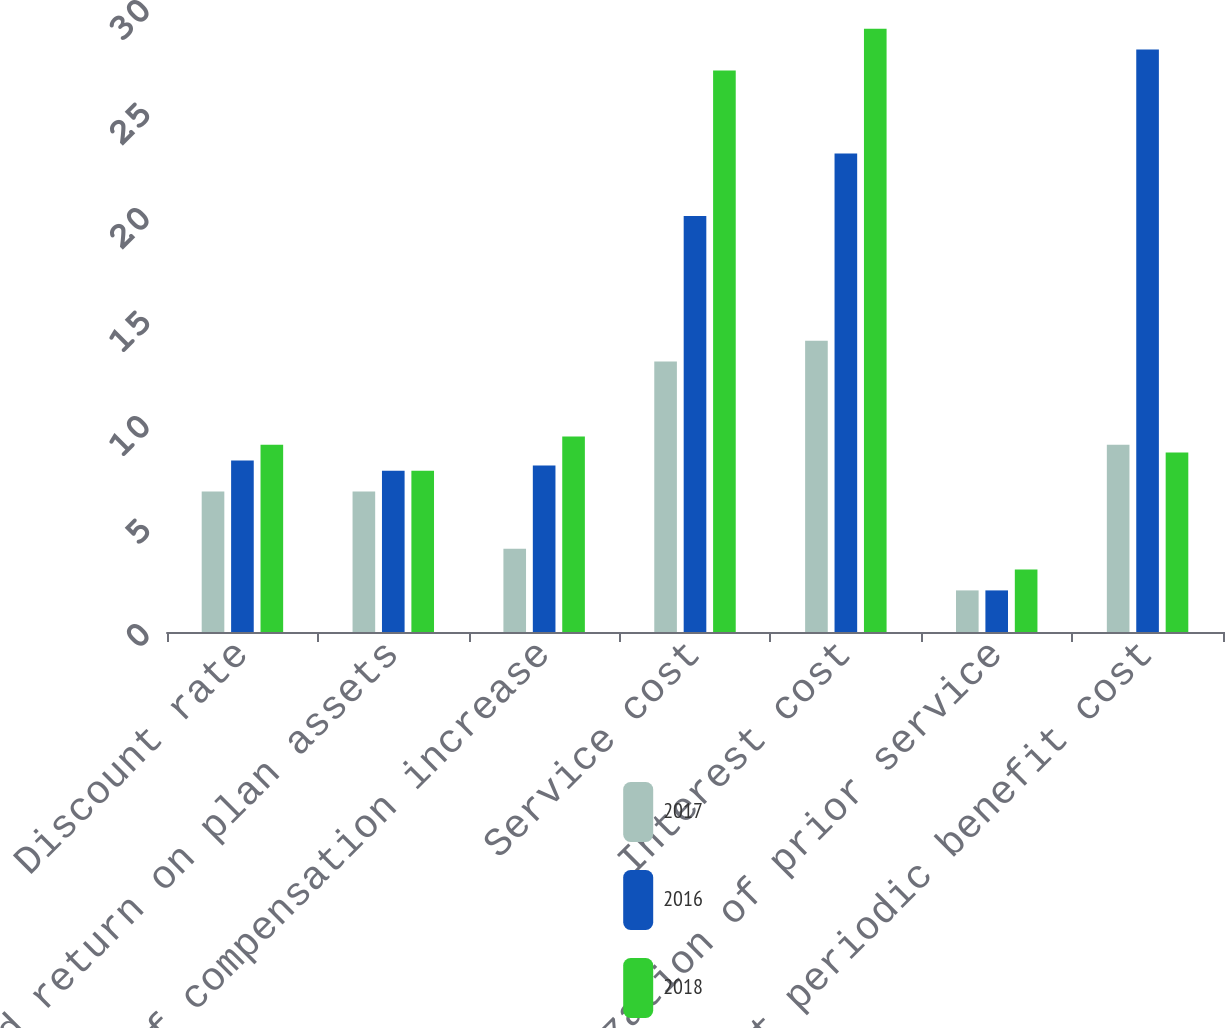Convert chart to OTSL. <chart><loc_0><loc_0><loc_500><loc_500><stacked_bar_chart><ecel><fcel>Discount rate<fcel>Expected return on plan assets<fcel>Rate of compensation increase<fcel>Service cost<fcel>Interest cost<fcel>Amortization of prior service<fcel>Net periodic benefit cost<nl><fcel>2017<fcel>6.75<fcel>6.75<fcel>4<fcel>13<fcel>14<fcel>2<fcel>9<nl><fcel>2016<fcel>8.25<fcel>7.75<fcel>8<fcel>20<fcel>23<fcel>2<fcel>28<nl><fcel>2018<fcel>9<fcel>7.75<fcel>9.4<fcel>27<fcel>29<fcel>3<fcel>8.625<nl></chart> 